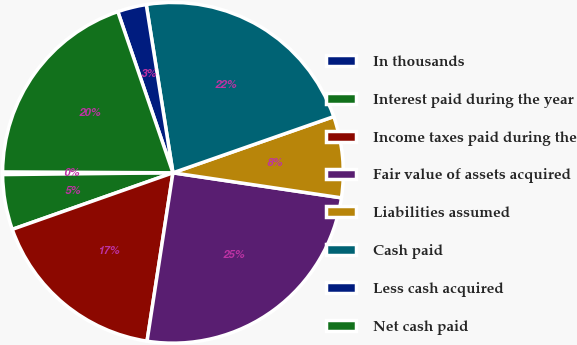Convert chart. <chart><loc_0><loc_0><loc_500><loc_500><pie_chart><fcel>In thousands<fcel>Interest paid during the year<fcel>Income taxes paid during the<fcel>Fair value of assets acquired<fcel>Liabilities assumed<fcel>Cash paid<fcel>Less cash acquired<fcel>Net cash paid<nl><fcel>0.25%<fcel>5.22%<fcel>17.18%<fcel>25.08%<fcel>7.7%<fcel>22.15%<fcel>2.74%<fcel>19.67%<nl></chart> 